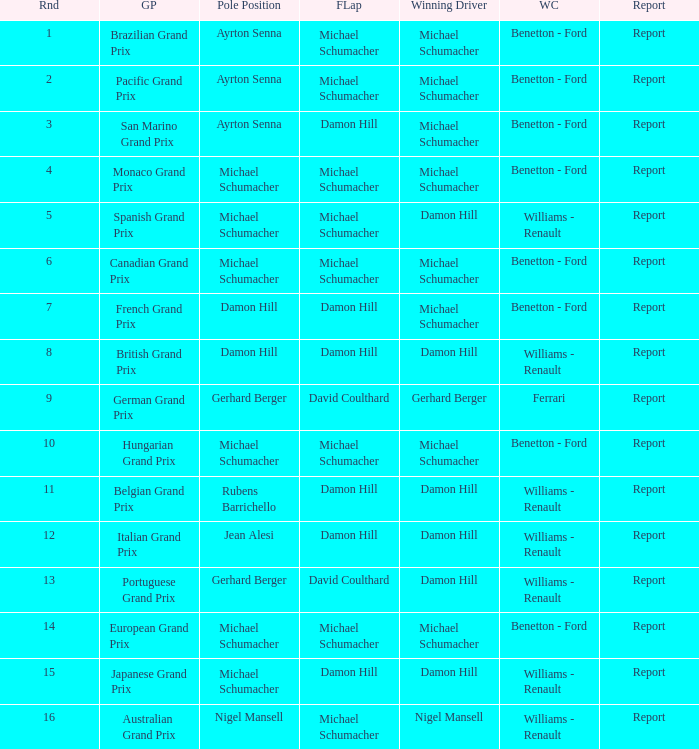Name the pole position at the japanese grand prix when the fastest lap is damon hill Michael Schumacher. 